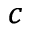Convert formula to latex. <formula><loc_0><loc_0><loc_500><loc_500>^ { c }</formula> 